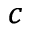Convert formula to latex. <formula><loc_0><loc_0><loc_500><loc_500>^ { c }</formula> 